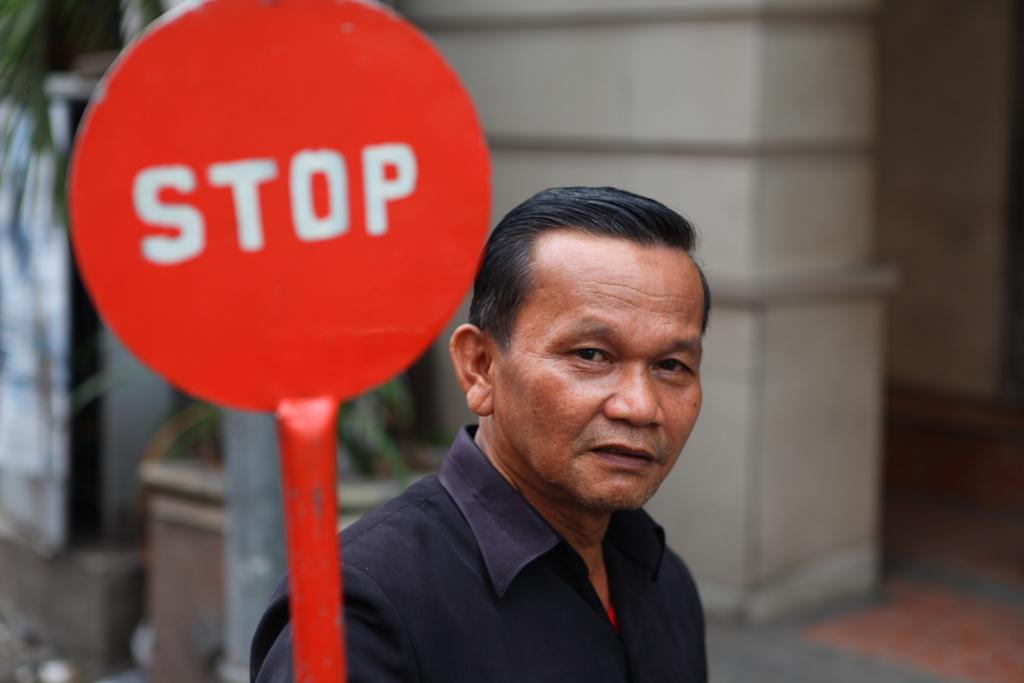What is the main object in the image? There is a sign board in the image. Can you describe the person in the image? There is a man wearing a black color shirt in the image. What is the background of the image? There is a wall in the image. What type of vegetation is on the left side of the image? There is a tree on the left side of the image. How many rings does the man in the image have on his fingers? There is no information about rings on the man's fingers in the image. How many brothers does the man in the image have? There is no information about the man's brothers in the image. 